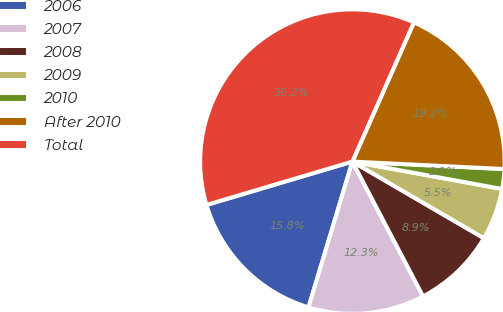Convert chart to OTSL. <chart><loc_0><loc_0><loc_500><loc_500><pie_chart><fcel>2006<fcel>2007<fcel>2008<fcel>2009<fcel>2010<fcel>After 2010<fcel>Total<nl><fcel>15.75%<fcel>12.34%<fcel>8.92%<fcel>5.51%<fcel>2.1%<fcel>19.16%<fcel>36.22%<nl></chart> 